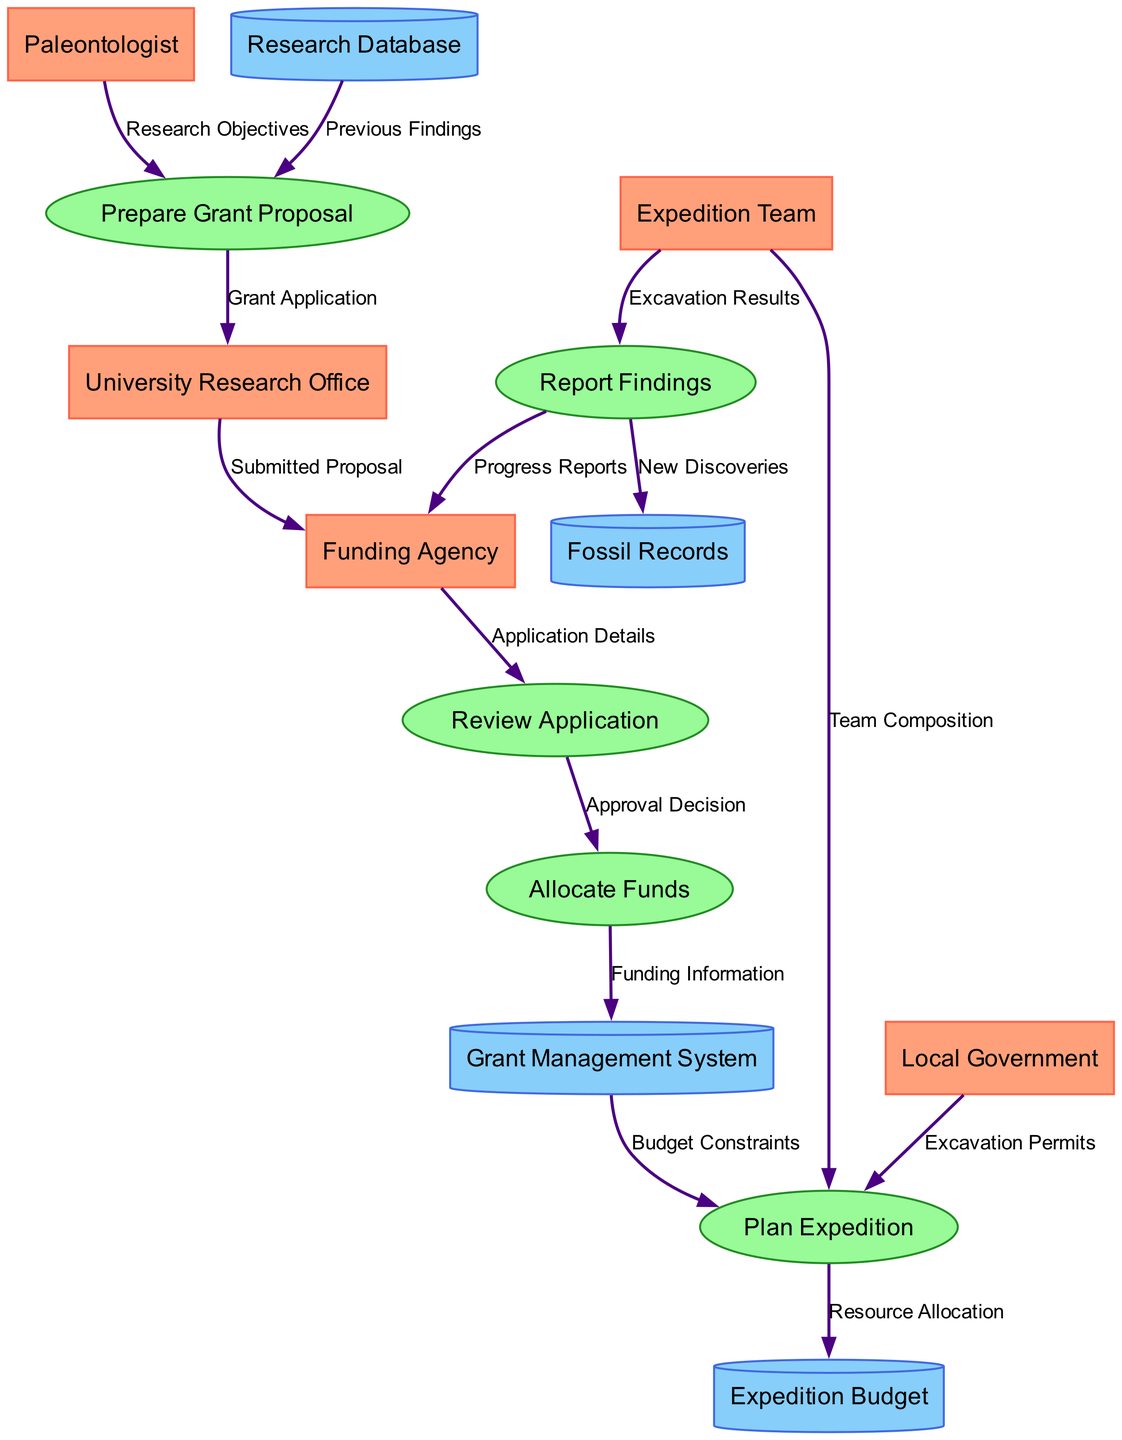What are the external entities involved in the diagram? The diagram includes five external entities: Paleontologist, University Research Office, Funding Agency, Expedition Team, and Local Government.
Answer: Paleontologist, University Research Office, Funding Agency, Expedition Team, Local Government How many processes are depicted in the diagram? There are five processes shown in the diagram: Prepare Grant Proposal, Review Application, Allocate Funds, Plan Expedition, and Report Findings.
Answer: Five What is the first data flow in the diagram? The first data flow is from the Paleontologist to Prepare Grant Proposal, labeled as Research Objectives.
Answer: Research Objectives Which entity submits the proposal to the Funding Agency? The University Research Office submits the proposal to the Funding Agency as indicated by the flow from University Research Office to Funding Agency labeled as Submitted Proposal.
Answer: University Research Office What does the Grant Management System receive from Allocate Funds? The Grant Management System receives Funding Information from the Allocate Funds process according to the flow described in the diagram.
Answer: Funding Information What information flows from the Funding Agency to the Review Application process? The Application Details flow from the Funding Agency to the Review Application process, which indicates that this information is crucial for the review process.
Answer: Application Details How does the Expedition Team contribute to the Plan Expedition process? The Expedition Team contributes by providing Team Composition, which is a critical element to be considered when planning the expedition, as shown in the flow from Expedition Team to Plan Expedition.
Answer: Team Composition Which process produces New Discoveries for the Fossil Records? The Report Findings process generates New Discoveries that are documented into Fossil Records, illustrating the culmination of the expedition's efforts in this flow.
Answer: Report Findings What is the final report sent to the Funding Agency from the Report Findings process? The final report sent is labeled Progress Reports, which summarizes the expedition outcomes and findings related to the funding agency.
Answer: Progress Reports 